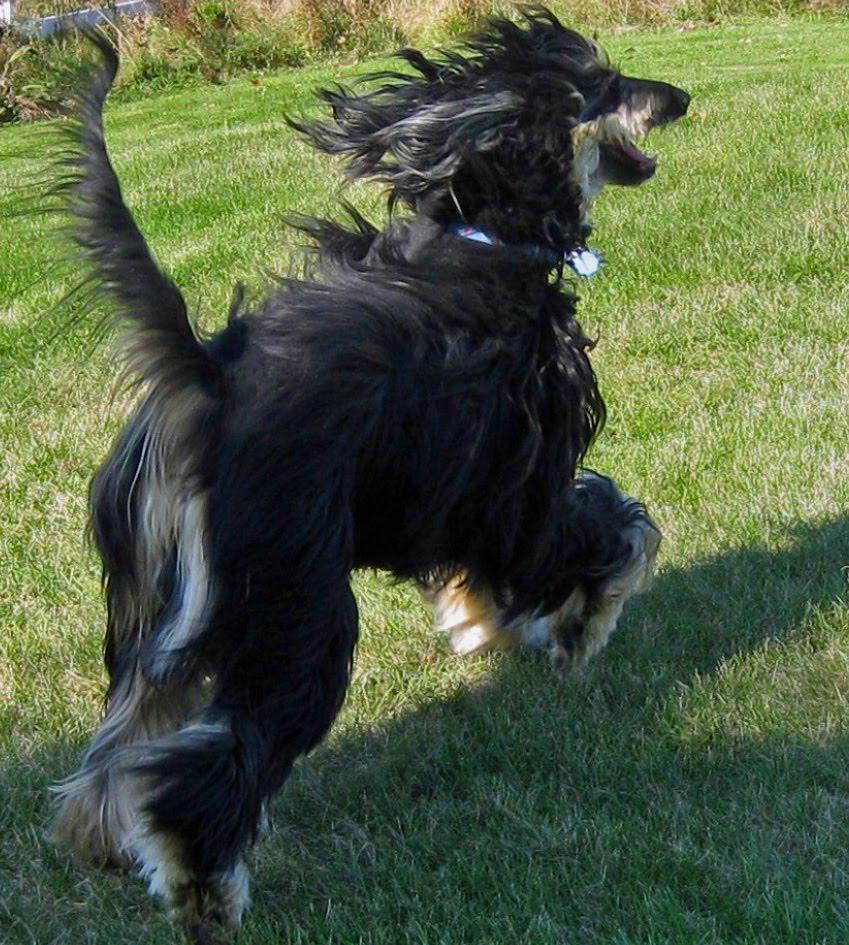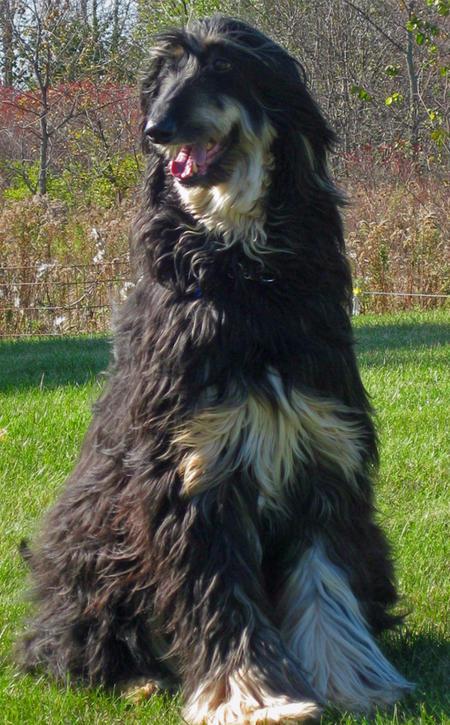The first image is the image on the left, the second image is the image on the right. Analyze the images presented: Is the assertion "One image shows a mostly black dog sitting upright in the grass." valid? Answer yes or no. Yes. 